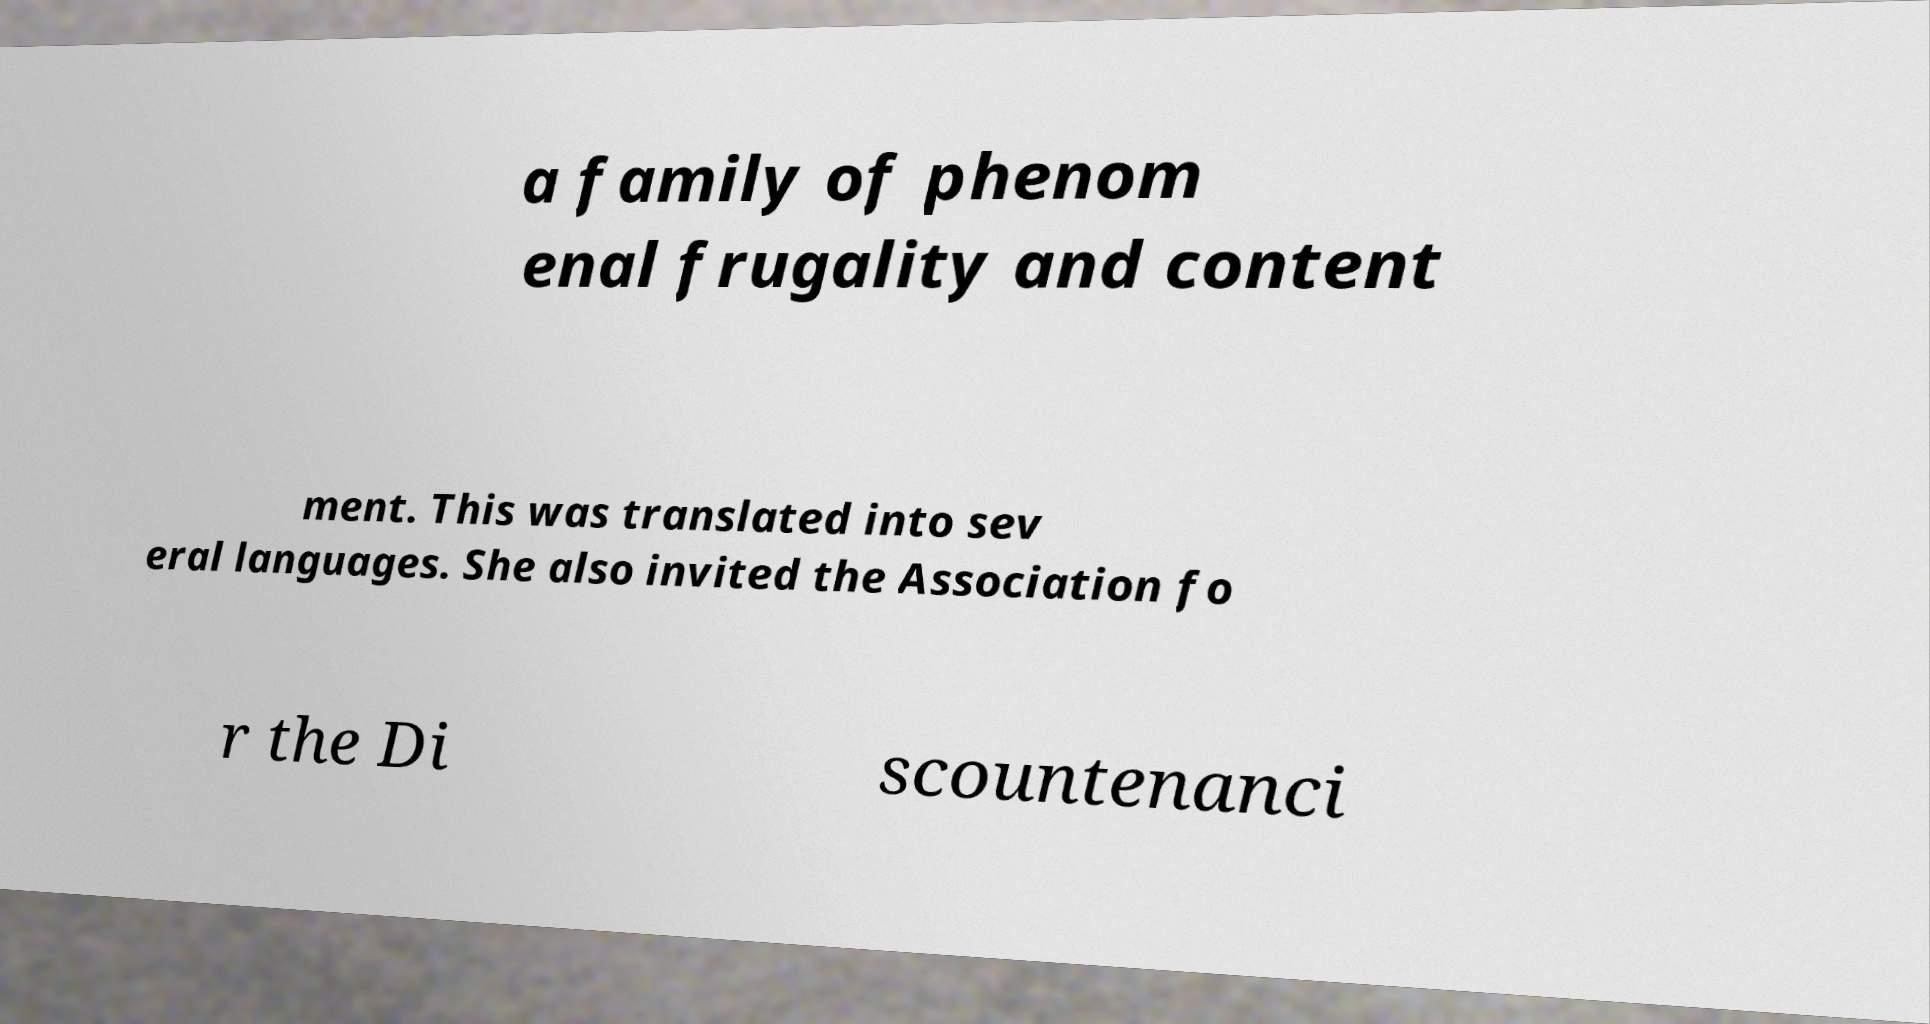Can you accurately transcribe the text from the provided image for me? a family of phenom enal frugality and content ment. This was translated into sev eral languages. She also invited the Association fo r the Di scountenanci 